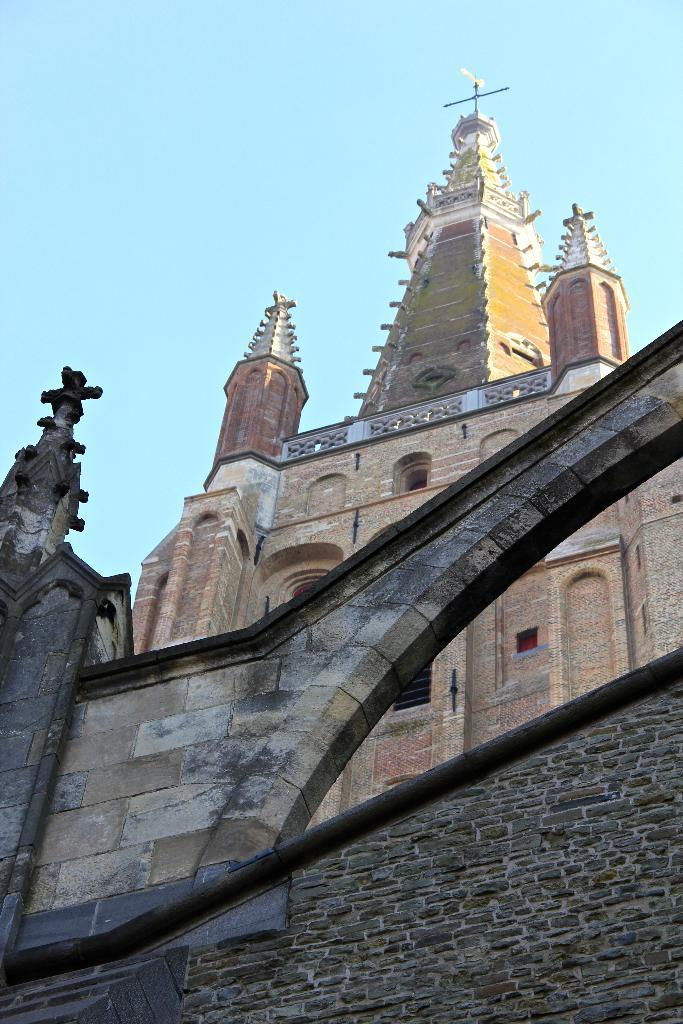What type of building can be seen in the picture? There is a church in the picture. What other objects or structures are present in the image? There is a wall in the picture. Are there any religious symbols visible in the image? Yes, cross symbols are present in the picture. What can be seen in the background of the image? The sky is visible in the picture. Can you tell me how many baskets are hanging from the church in the image? There are no baskets present in the image; it features a church with cross symbols and a wall. What type of request can be seen being made in the image? There is no request visible in the image; it only shows a church, a wall, and cross symbols. 